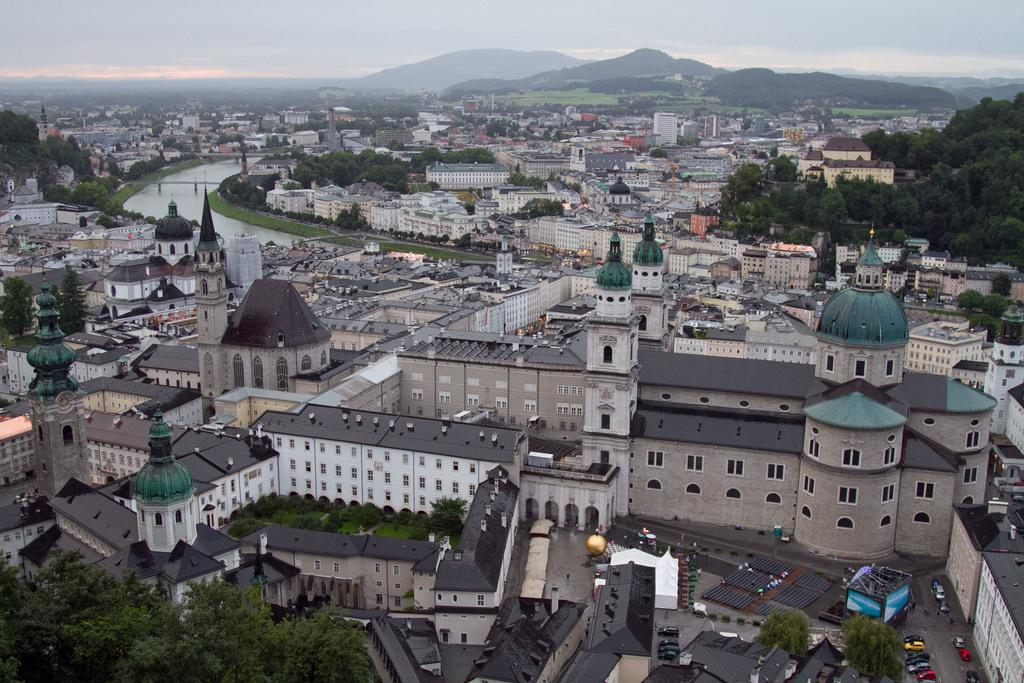What type of view is shown in the image? The image is an aerial view. What structures can be seen in the image? There are buildings in the image. What type of transportation is visible on the roads? There are vehicles on the road in the image. What natural feature can be seen in the image? There is water visible in the image. What type of vegetation is present in the image? There are trees in the image. What type of man-made structure is present in the image? There is a bridge in the image. What type of geographical feature is present in the image? There are hills in the image. What is visible in the background of the image? The sky is visible in the background of the image. What type of mint is growing on the hills in the image? There is no mint growing on the hills in the image; the image only shows trees and other vegetation. 